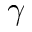<formula> <loc_0><loc_0><loc_500><loc_500>\gamma</formula> 